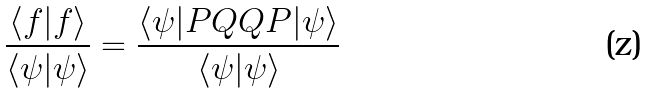<formula> <loc_0><loc_0><loc_500><loc_500>\frac { \langle f | f \rangle } { \langle \psi | \psi \rangle } = \frac { \langle \psi | P Q Q P | \psi \rangle } { \langle \psi | \psi \rangle }</formula> 